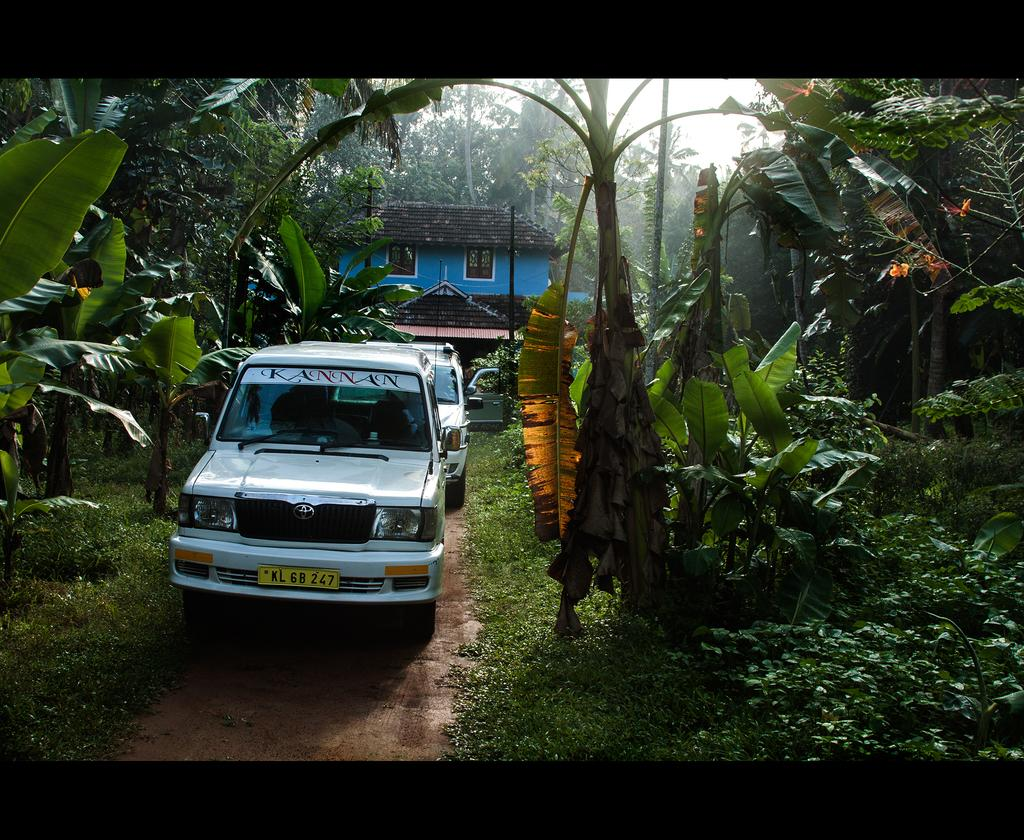Where was the picture taken? The picture was clicked outside. What can be seen in the center of the image? There are cars, grass, plants, trees, and a house in the center of the image. What is visible in the background of the image? The sky, trees, and other objects are visible in the background of the image. How much debt is being discussed in the image? There is no mention of debt in the image; it features a scene with cars, grass, plants, trees, a house, and a background with the sky and other objects. Can you tell me how many times the person in the image jumps? There is no person present in the image, and no jumping is depicted. 